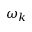Convert formula to latex. <formula><loc_0><loc_0><loc_500><loc_500>\omega _ { k }</formula> 